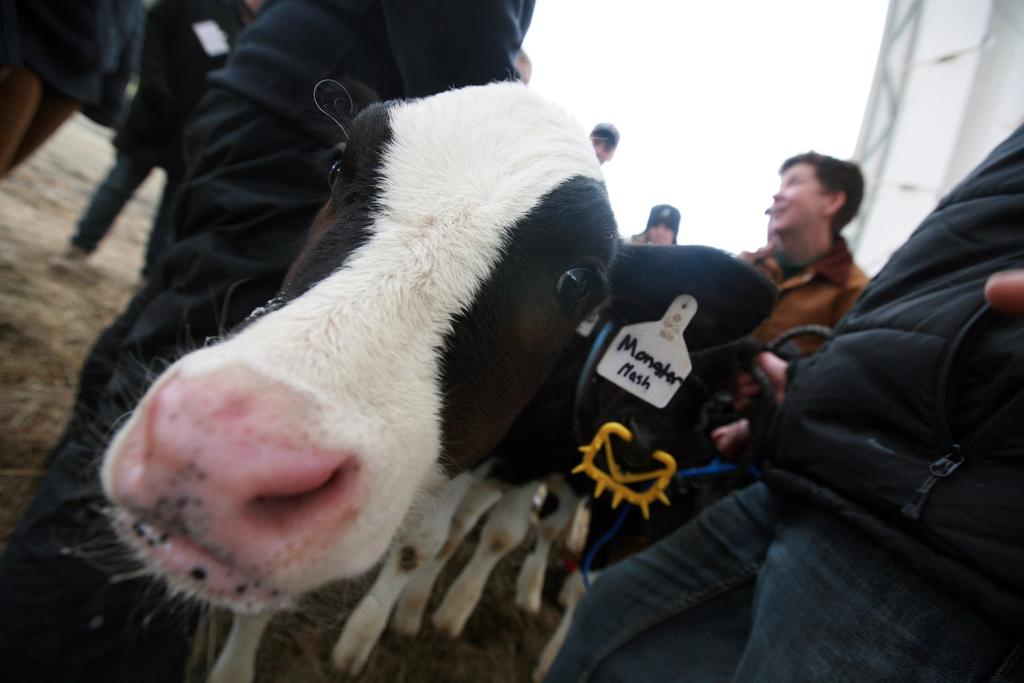What types of living beings are present in the image? There are animals and people in the image. What else can be seen in the image besides the living beings? There is written text in the image. What is visible in the background of the image? The sky is visible in the background of the image. Where are the babies located in the image? There are no babies present in the image. What type of fire can be seen in the image? There is no fire present in the image. 